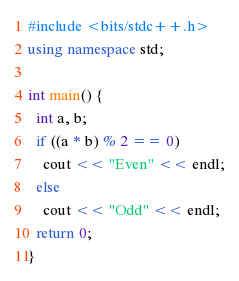Convert code to text. <code><loc_0><loc_0><loc_500><loc_500><_C++_>#include <bits/stdc++.h>
using namespace std;

int main() {
  int a, b;
  if ((a * b) % 2 == 0)
    cout << "Even" << endl;
  else
    cout << "Odd" << endl;
  return 0;
}</code> 